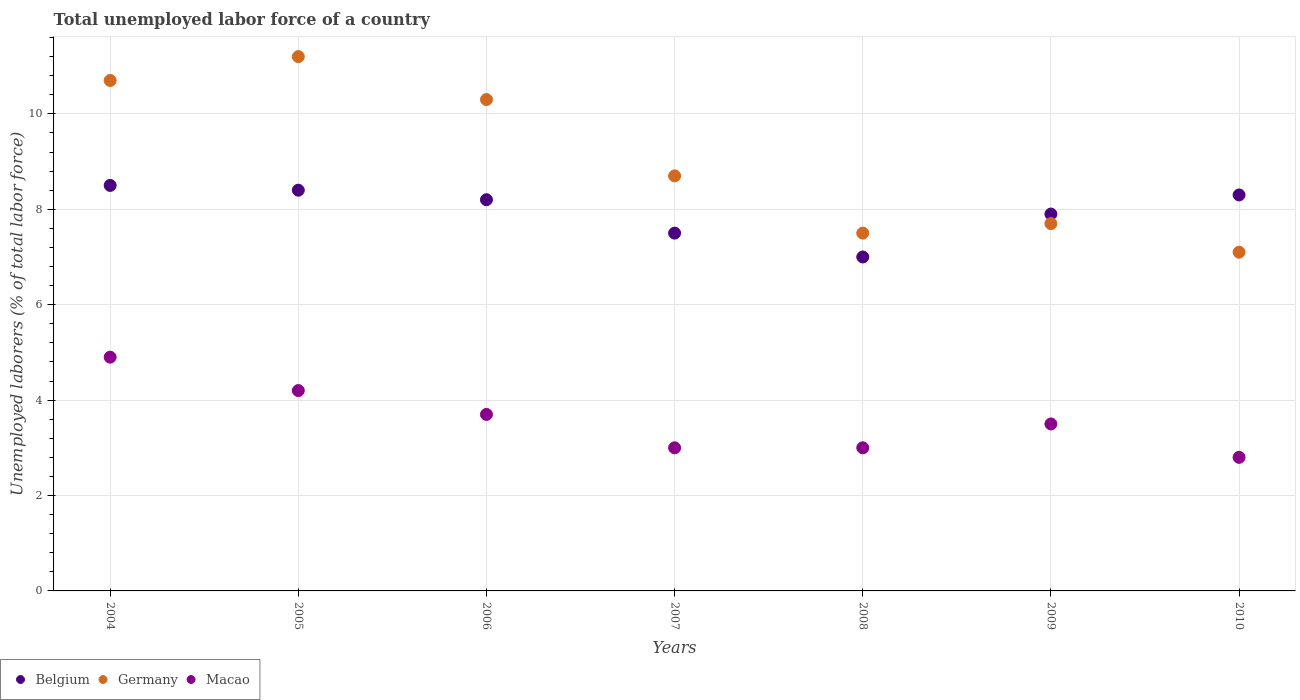Is the number of dotlines equal to the number of legend labels?
Your answer should be very brief. Yes. What is the total unemployed labor force in Macao in 2009?
Ensure brevity in your answer.  3.5. Across all years, what is the maximum total unemployed labor force in Belgium?
Make the answer very short. 8.5. Across all years, what is the minimum total unemployed labor force in Macao?
Your answer should be very brief. 2.8. In which year was the total unemployed labor force in Belgium minimum?
Give a very brief answer. 2008. What is the total total unemployed labor force in Belgium in the graph?
Provide a short and direct response. 55.8. What is the difference between the total unemployed labor force in Belgium in 2005 and that in 2009?
Your response must be concise. 0.5. What is the difference between the total unemployed labor force in Germany in 2006 and the total unemployed labor force in Macao in 2010?
Your answer should be very brief. 7.5. What is the average total unemployed labor force in Macao per year?
Provide a succinct answer. 3.59. In the year 2009, what is the difference between the total unemployed labor force in Belgium and total unemployed labor force in Macao?
Offer a very short reply. 4.4. What is the ratio of the total unemployed labor force in Germany in 2007 to that in 2009?
Provide a short and direct response. 1.13. Is the difference between the total unemployed labor force in Belgium in 2005 and 2007 greater than the difference between the total unemployed labor force in Macao in 2005 and 2007?
Ensure brevity in your answer.  No. What is the difference between the highest and the second highest total unemployed labor force in Belgium?
Provide a succinct answer. 0.1. What is the difference between the highest and the lowest total unemployed labor force in Belgium?
Your answer should be compact. 1.5. Is the sum of the total unemployed labor force in Macao in 2008 and 2009 greater than the maximum total unemployed labor force in Germany across all years?
Your response must be concise. No. Is it the case that in every year, the sum of the total unemployed labor force in Macao and total unemployed labor force in Belgium  is greater than the total unemployed labor force in Germany?
Make the answer very short. Yes. Does the total unemployed labor force in Macao monotonically increase over the years?
Offer a terse response. No. Is the total unemployed labor force in Macao strictly greater than the total unemployed labor force in Germany over the years?
Give a very brief answer. No. How many years are there in the graph?
Make the answer very short. 7. Are the values on the major ticks of Y-axis written in scientific E-notation?
Your answer should be very brief. No. Does the graph contain grids?
Make the answer very short. Yes. How many legend labels are there?
Make the answer very short. 3. How are the legend labels stacked?
Provide a succinct answer. Horizontal. What is the title of the graph?
Your answer should be compact. Total unemployed labor force of a country. What is the label or title of the X-axis?
Provide a short and direct response. Years. What is the label or title of the Y-axis?
Offer a very short reply. Unemployed laborers (% of total labor force). What is the Unemployed laborers (% of total labor force) of Belgium in 2004?
Ensure brevity in your answer.  8.5. What is the Unemployed laborers (% of total labor force) of Germany in 2004?
Give a very brief answer. 10.7. What is the Unemployed laborers (% of total labor force) of Macao in 2004?
Offer a terse response. 4.9. What is the Unemployed laborers (% of total labor force) of Belgium in 2005?
Offer a very short reply. 8.4. What is the Unemployed laborers (% of total labor force) in Germany in 2005?
Your answer should be compact. 11.2. What is the Unemployed laborers (% of total labor force) in Macao in 2005?
Keep it short and to the point. 4.2. What is the Unemployed laborers (% of total labor force) in Belgium in 2006?
Offer a very short reply. 8.2. What is the Unemployed laborers (% of total labor force) of Germany in 2006?
Offer a very short reply. 10.3. What is the Unemployed laborers (% of total labor force) of Macao in 2006?
Keep it short and to the point. 3.7. What is the Unemployed laborers (% of total labor force) of Germany in 2007?
Keep it short and to the point. 8.7. What is the Unemployed laborers (% of total labor force) of Macao in 2007?
Offer a terse response. 3. What is the Unemployed laborers (% of total labor force) in Germany in 2008?
Give a very brief answer. 7.5. What is the Unemployed laborers (% of total labor force) of Belgium in 2009?
Your answer should be compact. 7.9. What is the Unemployed laborers (% of total labor force) of Germany in 2009?
Keep it short and to the point. 7.7. What is the Unemployed laborers (% of total labor force) of Belgium in 2010?
Provide a short and direct response. 8.3. What is the Unemployed laborers (% of total labor force) in Germany in 2010?
Make the answer very short. 7.1. What is the Unemployed laborers (% of total labor force) in Macao in 2010?
Make the answer very short. 2.8. Across all years, what is the maximum Unemployed laborers (% of total labor force) in Belgium?
Keep it short and to the point. 8.5. Across all years, what is the maximum Unemployed laborers (% of total labor force) of Germany?
Your answer should be compact. 11.2. Across all years, what is the maximum Unemployed laborers (% of total labor force) in Macao?
Ensure brevity in your answer.  4.9. Across all years, what is the minimum Unemployed laborers (% of total labor force) in Belgium?
Give a very brief answer. 7. Across all years, what is the minimum Unemployed laborers (% of total labor force) in Germany?
Your answer should be very brief. 7.1. Across all years, what is the minimum Unemployed laborers (% of total labor force) in Macao?
Make the answer very short. 2.8. What is the total Unemployed laborers (% of total labor force) in Belgium in the graph?
Keep it short and to the point. 55.8. What is the total Unemployed laborers (% of total labor force) in Germany in the graph?
Your answer should be compact. 63.2. What is the total Unemployed laborers (% of total labor force) in Macao in the graph?
Make the answer very short. 25.1. What is the difference between the Unemployed laborers (% of total labor force) in Belgium in 2004 and that in 2006?
Offer a terse response. 0.3. What is the difference between the Unemployed laborers (% of total labor force) in Belgium in 2004 and that in 2007?
Your response must be concise. 1. What is the difference between the Unemployed laborers (% of total labor force) in Belgium in 2004 and that in 2008?
Give a very brief answer. 1.5. What is the difference between the Unemployed laborers (% of total labor force) of Macao in 2004 and that in 2008?
Give a very brief answer. 1.9. What is the difference between the Unemployed laborers (% of total labor force) in Germany in 2004 and that in 2009?
Your answer should be compact. 3. What is the difference between the Unemployed laborers (% of total labor force) in Belgium in 2005 and that in 2006?
Make the answer very short. 0.2. What is the difference between the Unemployed laborers (% of total labor force) of Germany in 2005 and that in 2006?
Offer a very short reply. 0.9. What is the difference between the Unemployed laborers (% of total labor force) of Belgium in 2005 and that in 2007?
Offer a terse response. 0.9. What is the difference between the Unemployed laborers (% of total labor force) of Germany in 2005 and that in 2007?
Provide a succinct answer. 2.5. What is the difference between the Unemployed laborers (% of total labor force) in Germany in 2005 and that in 2008?
Your response must be concise. 3.7. What is the difference between the Unemployed laborers (% of total labor force) of Macao in 2005 and that in 2008?
Provide a short and direct response. 1.2. What is the difference between the Unemployed laborers (% of total labor force) in Germany in 2005 and that in 2009?
Keep it short and to the point. 3.5. What is the difference between the Unemployed laborers (% of total labor force) in Germany in 2005 and that in 2010?
Your answer should be compact. 4.1. What is the difference between the Unemployed laborers (% of total labor force) in Macao in 2005 and that in 2010?
Provide a short and direct response. 1.4. What is the difference between the Unemployed laborers (% of total labor force) of Belgium in 2006 and that in 2008?
Your answer should be compact. 1.2. What is the difference between the Unemployed laborers (% of total labor force) of Germany in 2006 and that in 2008?
Ensure brevity in your answer.  2.8. What is the difference between the Unemployed laborers (% of total labor force) in Germany in 2006 and that in 2009?
Give a very brief answer. 2.6. What is the difference between the Unemployed laborers (% of total labor force) in Macao in 2006 and that in 2009?
Your response must be concise. 0.2. What is the difference between the Unemployed laborers (% of total labor force) of Germany in 2006 and that in 2010?
Your answer should be compact. 3.2. What is the difference between the Unemployed laborers (% of total labor force) in Germany in 2007 and that in 2008?
Provide a succinct answer. 1.2. What is the difference between the Unemployed laborers (% of total labor force) in Germany in 2007 and that in 2009?
Ensure brevity in your answer.  1. What is the difference between the Unemployed laborers (% of total labor force) in Macao in 2007 and that in 2009?
Offer a terse response. -0.5. What is the difference between the Unemployed laborers (% of total labor force) in Germany in 2007 and that in 2010?
Offer a terse response. 1.6. What is the difference between the Unemployed laborers (% of total labor force) of Macao in 2008 and that in 2009?
Offer a very short reply. -0.5. What is the difference between the Unemployed laborers (% of total labor force) of Germany in 2008 and that in 2010?
Give a very brief answer. 0.4. What is the difference between the Unemployed laborers (% of total labor force) in Macao in 2008 and that in 2010?
Offer a terse response. 0.2. What is the difference between the Unemployed laborers (% of total labor force) in Belgium in 2009 and that in 2010?
Make the answer very short. -0.4. What is the difference between the Unemployed laborers (% of total labor force) in Germany in 2004 and the Unemployed laborers (% of total labor force) in Macao in 2005?
Your answer should be compact. 6.5. What is the difference between the Unemployed laborers (% of total labor force) in Belgium in 2004 and the Unemployed laborers (% of total labor force) in Germany in 2007?
Make the answer very short. -0.2. What is the difference between the Unemployed laborers (% of total labor force) in Belgium in 2004 and the Unemployed laborers (% of total labor force) in Macao in 2007?
Offer a very short reply. 5.5. What is the difference between the Unemployed laborers (% of total labor force) of Germany in 2004 and the Unemployed laborers (% of total labor force) of Macao in 2007?
Keep it short and to the point. 7.7. What is the difference between the Unemployed laborers (% of total labor force) in Belgium in 2004 and the Unemployed laborers (% of total labor force) in Macao in 2008?
Provide a short and direct response. 5.5. What is the difference between the Unemployed laborers (% of total labor force) of Belgium in 2004 and the Unemployed laborers (% of total labor force) of Germany in 2009?
Give a very brief answer. 0.8. What is the difference between the Unemployed laborers (% of total labor force) of Belgium in 2004 and the Unemployed laborers (% of total labor force) of Macao in 2009?
Provide a short and direct response. 5. What is the difference between the Unemployed laborers (% of total labor force) in Germany in 2004 and the Unemployed laborers (% of total labor force) in Macao in 2009?
Ensure brevity in your answer.  7.2. What is the difference between the Unemployed laborers (% of total labor force) in Belgium in 2004 and the Unemployed laborers (% of total labor force) in Germany in 2010?
Keep it short and to the point. 1.4. What is the difference between the Unemployed laborers (% of total labor force) of Belgium in 2005 and the Unemployed laborers (% of total labor force) of Germany in 2006?
Your response must be concise. -1.9. What is the difference between the Unemployed laborers (% of total labor force) of Belgium in 2005 and the Unemployed laborers (% of total labor force) of Macao in 2006?
Give a very brief answer. 4.7. What is the difference between the Unemployed laborers (% of total labor force) in Germany in 2005 and the Unemployed laborers (% of total labor force) in Macao in 2006?
Make the answer very short. 7.5. What is the difference between the Unemployed laborers (% of total labor force) of Belgium in 2005 and the Unemployed laborers (% of total labor force) of Macao in 2007?
Offer a very short reply. 5.4. What is the difference between the Unemployed laborers (% of total labor force) of Germany in 2005 and the Unemployed laborers (% of total labor force) of Macao in 2007?
Your answer should be very brief. 8.2. What is the difference between the Unemployed laborers (% of total labor force) of Belgium in 2005 and the Unemployed laborers (% of total labor force) of Germany in 2008?
Offer a terse response. 0.9. What is the difference between the Unemployed laborers (% of total labor force) of Belgium in 2005 and the Unemployed laborers (% of total labor force) of Macao in 2008?
Provide a short and direct response. 5.4. What is the difference between the Unemployed laborers (% of total labor force) in Belgium in 2005 and the Unemployed laborers (% of total labor force) in Germany in 2009?
Offer a very short reply. 0.7. What is the difference between the Unemployed laborers (% of total labor force) in Belgium in 2005 and the Unemployed laborers (% of total labor force) in Macao in 2009?
Provide a short and direct response. 4.9. What is the difference between the Unemployed laborers (% of total labor force) of Belgium in 2005 and the Unemployed laborers (% of total labor force) of Germany in 2010?
Give a very brief answer. 1.3. What is the difference between the Unemployed laborers (% of total labor force) of Belgium in 2006 and the Unemployed laborers (% of total labor force) of Germany in 2007?
Provide a short and direct response. -0.5. What is the difference between the Unemployed laborers (% of total labor force) in Germany in 2006 and the Unemployed laborers (% of total labor force) in Macao in 2008?
Give a very brief answer. 7.3. What is the difference between the Unemployed laborers (% of total labor force) in Belgium in 2006 and the Unemployed laborers (% of total labor force) in Macao in 2009?
Your answer should be compact. 4.7. What is the difference between the Unemployed laborers (% of total labor force) of Germany in 2006 and the Unemployed laborers (% of total labor force) of Macao in 2009?
Provide a succinct answer. 6.8. What is the difference between the Unemployed laborers (% of total labor force) of Belgium in 2006 and the Unemployed laborers (% of total labor force) of Germany in 2010?
Keep it short and to the point. 1.1. What is the difference between the Unemployed laborers (% of total labor force) in Belgium in 2006 and the Unemployed laborers (% of total labor force) in Macao in 2010?
Provide a succinct answer. 5.4. What is the difference between the Unemployed laborers (% of total labor force) in Belgium in 2007 and the Unemployed laborers (% of total labor force) in Germany in 2008?
Provide a short and direct response. 0. What is the difference between the Unemployed laborers (% of total labor force) of Belgium in 2007 and the Unemployed laborers (% of total labor force) of Macao in 2008?
Ensure brevity in your answer.  4.5. What is the difference between the Unemployed laborers (% of total labor force) of Belgium in 2007 and the Unemployed laborers (% of total labor force) of Macao in 2009?
Offer a terse response. 4. What is the difference between the Unemployed laborers (% of total labor force) in Germany in 2007 and the Unemployed laborers (% of total labor force) in Macao in 2009?
Your response must be concise. 5.2. What is the difference between the Unemployed laborers (% of total labor force) of Belgium in 2007 and the Unemployed laborers (% of total labor force) of Germany in 2010?
Ensure brevity in your answer.  0.4. What is the difference between the Unemployed laborers (% of total labor force) of Germany in 2007 and the Unemployed laborers (% of total labor force) of Macao in 2010?
Keep it short and to the point. 5.9. What is the difference between the Unemployed laborers (% of total labor force) in Belgium in 2008 and the Unemployed laborers (% of total labor force) in Germany in 2009?
Keep it short and to the point. -0.7. What is the difference between the Unemployed laborers (% of total labor force) in Belgium in 2008 and the Unemployed laborers (% of total labor force) in Macao in 2009?
Make the answer very short. 3.5. What is the difference between the Unemployed laborers (% of total labor force) of Belgium in 2008 and the Unemployed laborers (% of total labor force) of Germany in 2010?
Make the answer very short. -0.1. What is the difference between the Unemployed laborers (% of total labor force) of Belgium in 2008 and the Unemployed laborers (% of total labor force) of Macao in 2010?
Give a very brief answer. 4.2. What is the difference between the Unemployed laborers (% of total labor force) in Germany in 2008 and the Unemployed laborers (% of total labor force) in Macao in 2010?
Make the answer very short. 4.7. What is the difference between the Unemployed laborers (% of total labor force) of Belgium in 2009 and the Unemployed laborers (% of total labor force) of Macao in 2010?
Offer a terse response. 5.1. What is the difference between the Unemployed laborers (% of total labor force) of Germany in 2009 and the Unemployed laborers (% of total labor force) of Macao in 2010?
Your response must be concise. 4.9. What is the average Unemployed laborers (% of total labor force) of Belgium per year?
Give a very brief answer. 7.97. What is the average Unemployed laborers (% of total labor force) of Germany per year?
Provide a succinct answer. 9.03. What is the average Unemployed laborers (% of total labor force) of Macao per year?
Make the answer very short. 3.59. In the year 2004, what is the difference between the Unemployed laborers (% of total labor force) of Belgium and Unemployed laborers (% of total labor force) of Macao?
Keep it short and to the point. 3.6. In the year 2006, what is the difference between the Unemployed laborers (% of total labor force) of Belgium and Unemployed laborers (% of total labor force) of Germany?
Your response must be concise. -2.1. In the year 2006, what is the difference between the Unemployed laborers (% of total labor force) in Germany and Unemployed laborers (% of total labor force) in Macao?
Your response must be concise. 6.6. In the year 2008, what is the difference between the Unemployed laborers (% of total labor force) in Belgium and Unemployed laborers (% of total labor force) in Germany?
Offer a terse response. -0.5. In the year 2008, what is the difference between the Unemployed laborers (% of total labor force) of Belgium and Unemployed laborers (% of total labor force) of Macao?
Ensure brevity in your answer.  4. In the year 2009, what is the difference between the Unemployed laborers (% of total labor force) of Belgium and Unemployed laborers (% of total labor force) of Macao?
Give a very brief answer. 4.4. In the year 2009, what is the difference between the Unemployed laborers (% of total labor force) in Germany and Unemployed laborers (% of total labor force) in Macao?
Offer a very short reply. 4.2. In the year 2010, what is the difference between the Unemployed laborers (% of total labor force) in Belgium and Unemployed laborers (% of total labor force) in Macao?
Your response must be concise. 5.5. In the year 2010, what is the difference between the Unemployed laborers (% of total labor force) of Germany and Unemployed laborers (% of total labor force) of Macao?
Your answer should be compact. 4.3. What is the ratio of the Unemployed laborers (% of total labor force) of Belgium in 2004 to that in 2005?
Your answer should be compact. 1.01. What is the ratio of the Unemployed laborers (% of total labor force) in Germany in 2004 to that in 2005?
Make the answer very short. 0.96. What is the ratio of the Unemployed laborers (% of total labor force) of Macao in 2004 to that in 2005?
Ensure brevity in your answer.  1.17. What is the ratio of the Unemployed laborers (% of total labor force) of Belgium in 2004 to that in 2006?
Keep it short and to the point. 1.04. What is the ratio of the Unemployed laborers (% of total labor force) of Germany in 2004 to that in 2006?
Provide a succinct answer. 1.04. What is the ratio of the Unemployed laborers (% of total labor force) in Macao in 2004 to that in 2006?
Provide a succinct answer. 1.32. What is the ratio of the Unemployed laborers (% of total labor force) of Belgium in 2004 to that in 2007?
Ensure brevity in your answer.  1.13. What is the ratio of the Unemployed laborers (% of total labor force) in Germany in 2004 to that in 2007?
Your answer should be compact. 1.23. What is the ratio of the Unemployed laborers (% of total labor force) of Macao in 2004 to that in 2007?
Provide a succinct answer. 1.63. What is the ratio of the Unemployed laborers (% of total labor force) of Belgium in 2004 to that in 2008?
Your response must be concise. 1.21. What is the ratio of the Unemployed laborers (% of total labor force) in Germany in 2004 to that in 2008?
Keep it short and to the point. 1.43. What is the ratio of the Unemployed laborers (% of total labor force) in Macao in 2004 to that in 2008?
Your response must be concise. 1.63. What is the ratio of the Unemployed laborers (% of total labor force) in Belgium in 2004 to that in 2009?
Keep it short and to the point. 1.08. What is the ratio of the Unemployed laborers (% of total labor force) in Germany in 2004 to that in 2009?
Ensure brevity in your answer.  1.39. What is the ratio of the Unemployed laborers (% of total labor force) in Belgium in 2004 to that in 2010?
Provide a succinct answer. 1.02. What is the ratio of the Unemployed laborers (% of total labor force) of Germany in 2004 to that in 2010?
Your answer should be compact. 1.51. What is the ratio of the Unemployed laborers (% of total labor force) in Belgium in 2005 to that in 2006?
Your response must be concise. 1.02. What is the ratio of the Unemployed laborers (% of total labor force) in Germany in 2005 to that in 2006?
Make the answer very short. 1.09. What is the ratio of the Unemployed laborers (% of total labor force) of Macao in 2005 to that in 2006?
Provide a short and direct response. 1.14. What is the ratio of the Unemployed laborers (% of total labor force) in Belgium in 2005 to that in 2007?
Provide a short and direct response. 1.12. What is the ratio of the Unemployed laborers (% of total labor force) of Germany in 2005 to that in 2007?
Make the answer very short. 1.29. What is the ratio of the Unemployed laborers (% of total labor force) of Germany in 2005 to that in 2008?
Offer a terse response. 1.49. What is the ratio of the Unemployed laborers (% of total labor force) in Belgium in 2005 to that in 2009?
Give a very brief answer. 1.06. What is the ratio of the Unemployed laborers (% of total labor force) of Germany in 2005 to that in 2009?
Provide a short and direct response. 1.45. What is the ratio of the Unemployed laborers (% of total labor force) of Germany in 2005 to that in 2010?
Offer a very short reply. 1.58. What is the ratio of the Unemployed laborers (% of total labor force) of Belgium in 2006 to that in 2007?
Give a very brief answer. 1.09. What is the ratio of the Unemployed laborers (% of total labor force) in Germany in 2006 to that in 2007?
Your response must be concise. 1.18. What is the ratio of the Unemployed laborers (% of total labor force) in Macao in 2006 to that in 2007?
Your answer should be very brief. 1.23. What is the ratio of the Unemployed laborers (% of total labor force) in Belgium in 2006 to that in 2008?
Provide a short and direct response. 1.17. What is the ratio of the Unemployed laborers (% of total labor force) in Germany in 2006 to that in 2008?
Provide a succinct answer. 1.37. What is the ratio of the Unemployed laborers (% of total labor force) of Macao in 2006 to that in 2008?
Ensure brevity in your answer.  1.23. What is the ratio of the Unemployed laborers (% of total labor force) of Belgium in 2006 to that in 2009?
Make the answer very short. 1.04. What is the ratio of the Unemployed laborers (% of total labor force) of Germany in 2006 to that in 2009?
Provide a short and direct response. 1.34. What is the ratio of the Unemployed laborers (% of total labor force) of Macao in 2006 to that in 2009?
Ensure brevity in your answer.  1.06. What is the ratio of the Unemployed laborers (% of total labor force) in Belgium in 2006 to that in 2010?
Provide a succinct answer. 0.99. What is the ratio of the Unemployed laborers (% of total labor force) of Germany in 2006 to that in 2010?
Offer a very short reply. 1.45. What is the ratio of the Unemployed laborers (% of total labor force) of Macao in 2006 to that in 2010?
Provide a succinct answer. 1.32. What is the ratio of the Unemployed laborers (% of total labor force) in Belgium in 2007 to that in 2008?
Provide a short and direct response. 1.07. What is the ratio of the Unemployed laborers (% of total labor force) in Germany in 2007 to that in 2008?
Provide a succinct answer. 1.16. What is the ratio of the Unemployed laborers (% of total labor force) of Macao in 2007 to that in 2008?
Make the answer very short. 1. What is the ratio of the Unemployed laborers (% of total labor force) in Belgium in 2007 to that in 2009?
Ensure brevity in your answer.  0.95. What is the ratio of the Unemployed laborers (% of total labor force) of Germany in 2007 to that in 2009?
Keep it short and to the point. 1.13. What is the ratio of the Unemployed laborers (% of total labor force) in Belgium in 2007 to that in 2010?
Your answer should be compact. 0.9. What is the ratio of the Unemployed laborers (% of total labor force) in Germany in 2007 to that in 2010?
Offer a very short reply. 1.23. What is the ratio of the Unemployed laborers (% of total labor force) in Macao in 2007 to that in 2010?
Offer a very short reply. 1.07. What is the ratio of the Unemployed laborers (% of total labor force) of Belgium in 2008 to that in 2009?
Your response must be concise. 0.89. What is the ratio of the Unemployed laborers (% of total labor force) in Germany in 2008 to that in 2009?
Keep it short and to the point. 0.97. What is the ratio of the Unemployed laborers (% of total labor force) of Macao in 2008 to that in 2009?
Your answer should be compact. 0.86. What is the ratio of the Unemployed laborers (% of total labor force) in Belgium in 2008 to that in 2010?
Give a very brief answer. 0.84. What is the ratio of the Unemployed laborers (% of total labor force) of Germany in 2008 to that in 2010?
Your answer should be compact. 1.06. What is the ratio of the Unemployed laborers (% of total labor force) in Macao in 2008 to that in 2010?
Your response must be concise. 1.07. What is the ratio of the Unemployed laborers (% of total labor force) in Belgium in 2009 to that in 2010?
Offer a terse response. 0.95. What is the ratio of the Unemployed laborers (% of total labor force) of Germany in 2009 to that in 2010?
Your answer should be compact. 1.08. What is the difference between the highest and the lowest Unemployed laborers (% of total labor force) in Belgium?
Ensure brevity in your answer.  1.5. What is the difference between the highest and the lowest Unemployed laborers (% of total labor force) in Macao?
Your answer should be very brief. 2.1. 